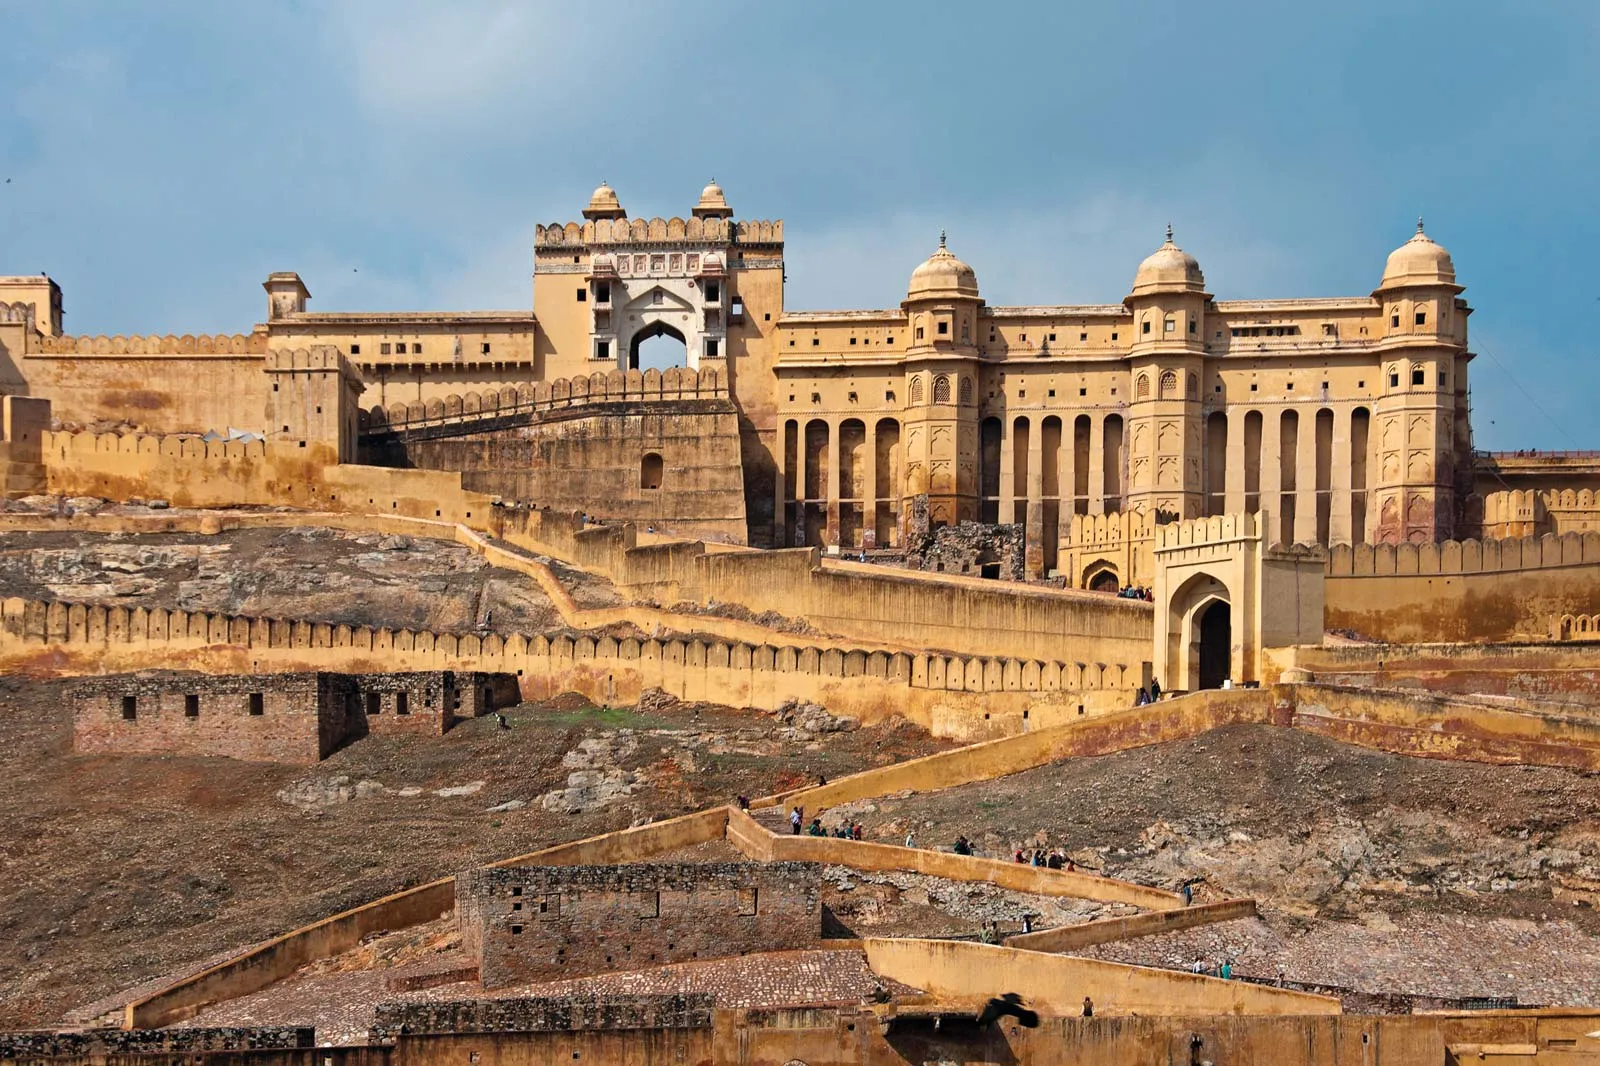Can you describe the architectural style of this fort in detail? The Amber Fort illustrates a beautiful fusion of Hindu and Mughal architectural styles, known for its artistic mastery and prowess. The fort is built from red and yellow sandstone and white marble, and comprises several large complexes with courtyards, halls, and rooms adorned with intricate carvings and mirror work. The majestic entrance, Ganesh Pol, is richly decorated, and the Diwan-e-Aam, or Hall of Public Audience, features impressive colonnades and exquisite arches. The Sheesh Mahal, or Mirror Palace, is renowned for its elaborate mirror mosaics and colored glasses. The fort also includes the Suhag Mandir, where royal women worshipped, and the charming garden, Kesar Kyari, laid out in a star shape with beautiful plantations. What kind of activities might have taken place in this fort during its peak? During its peak, the Amber Fort was a buzzing hub of royal activities and administration. The Diwan-e-Aam, or Hall of Public Audience, was where the king addressed the general public and discussed administrative matters. The Diwan-e-Khas, or Hall of Private Audience, hosted private meetings and discussions with esteemed visitors and dignitaries. The fort's courtyards and gardens were venues for celebrations, feasts, and cultural performances. Royal processions and ceremonial events would often take place here, showcasing the kingdom's grandeur and opulence. The Sheesh Mahal, with its reflective mosaics, created enchanting ambiances during royal gatherings at night with candlelight, making it a favorite spot for the royalty. The fort also had residential quarters for the king's family and ministers, with daily life revolving around administration, meetings, and royal leisure. 